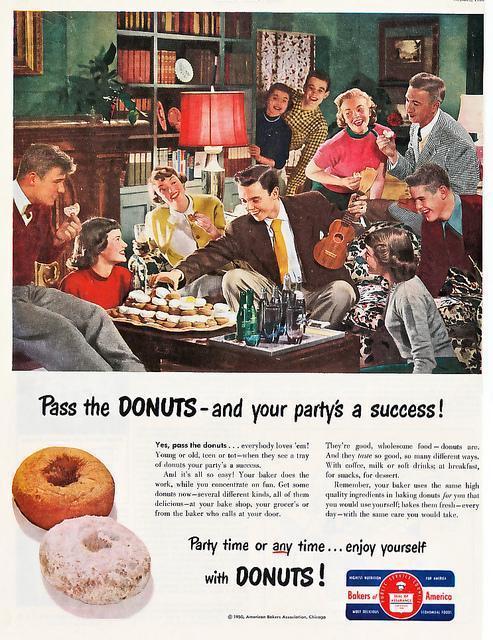How many people are in the picture?
Give a very brief answer. 10. How many donuts are there?
Give a very brief answer. 2. How many slices of pizza are left of the fork?
Give a very brief answer. 0. 